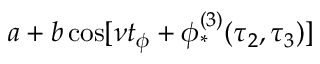<formula> <loc_0><loc_0><loc_500><loc_500>a + b \cos [ \nu t _ { \phi } + \phi _ { * } ^ { ( 3 ) } ( \tau _ { 2 } , \tau _ { 3 } ) ]</formula> 